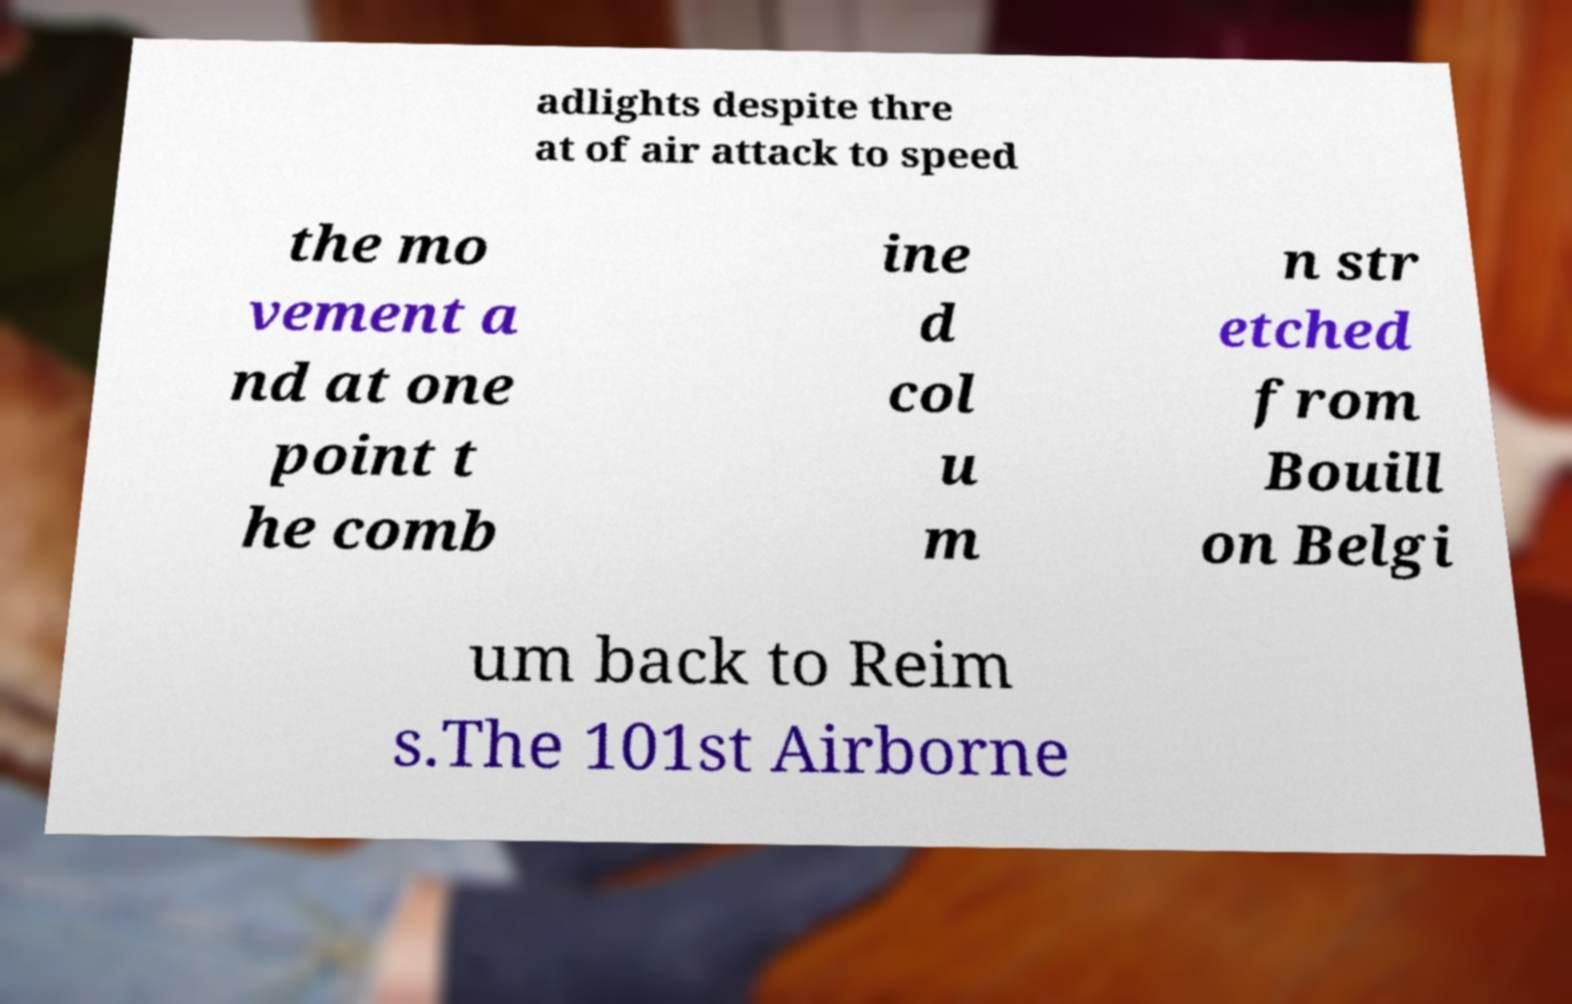Please read and relay the text visible in this image. What does it say? adlights despite thre at of air attack to speed the mo vement a nd at one point t he comb ine d col u m n str etched from Bouill on Belgi um back to Reim s.The 101st Airborne 